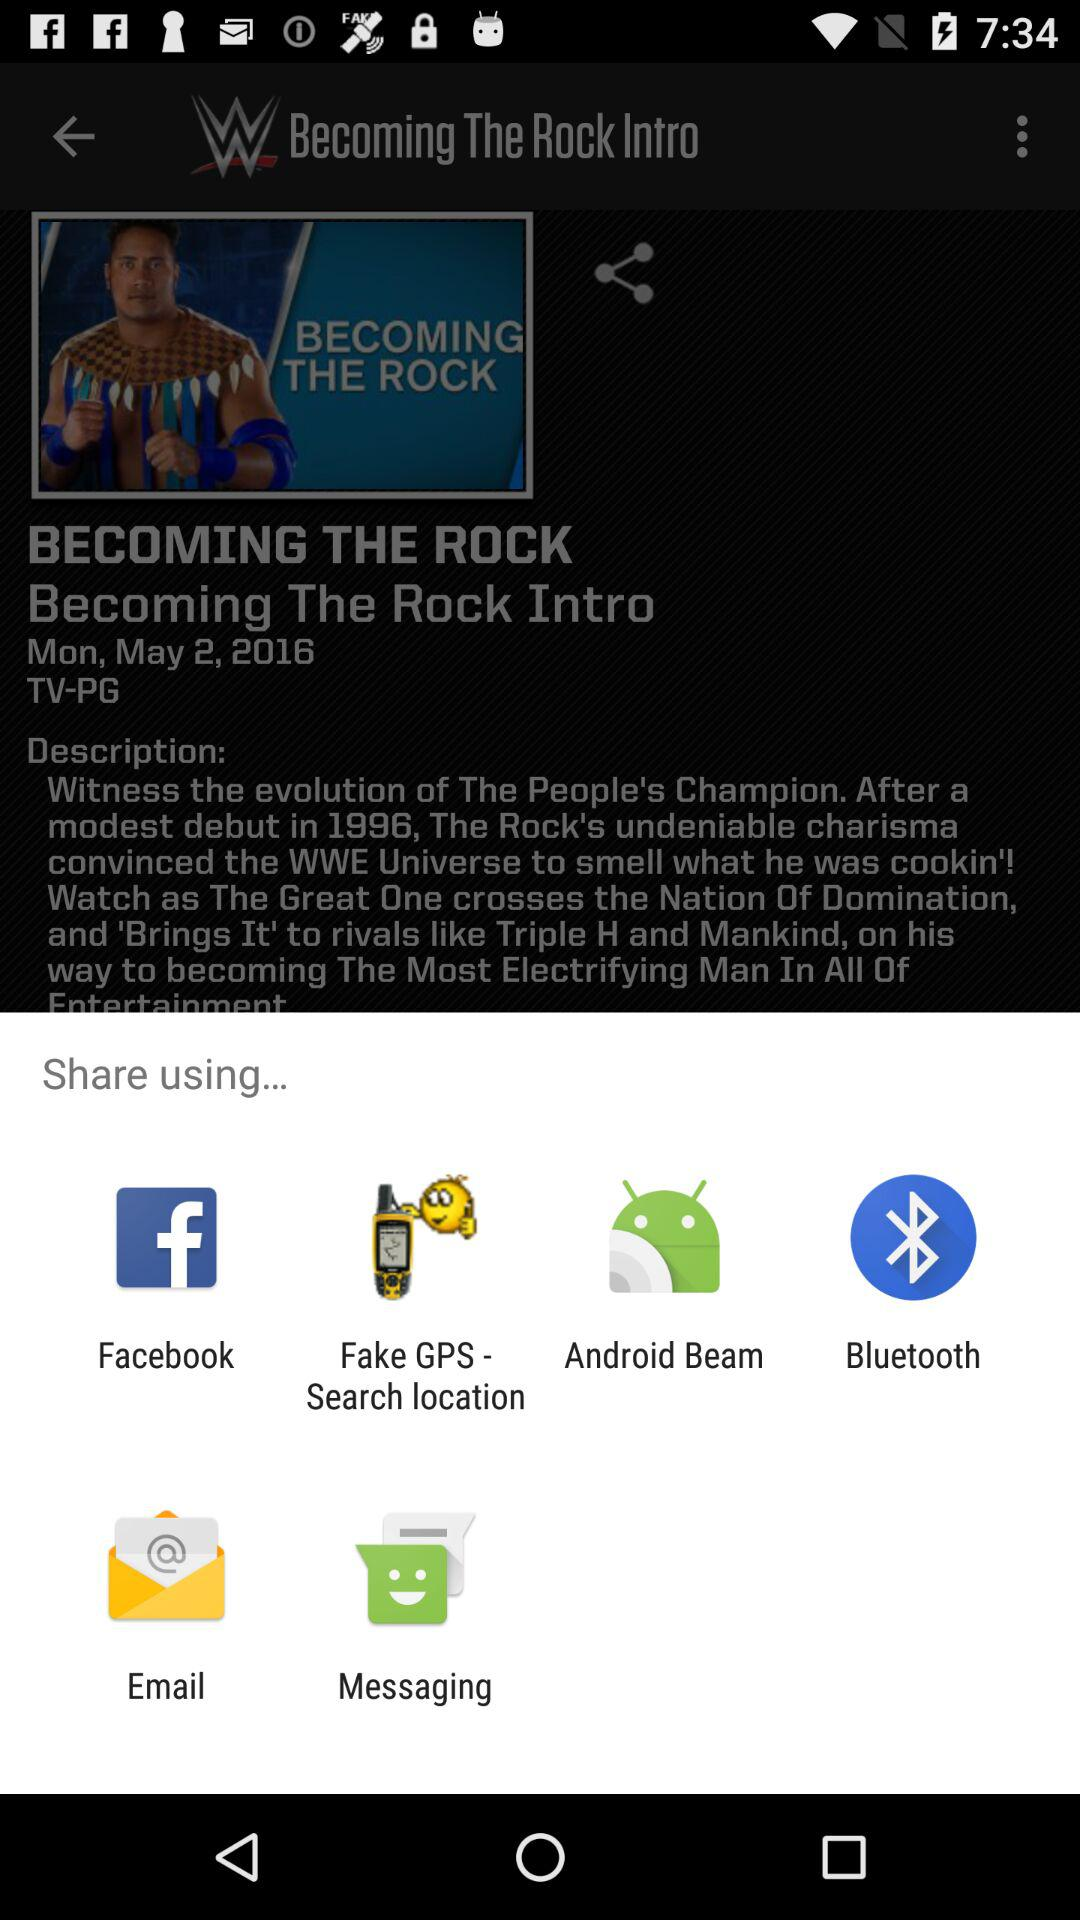What time was this published?
When the provided information is insufficient, respond with <no answer>. <no answer> 